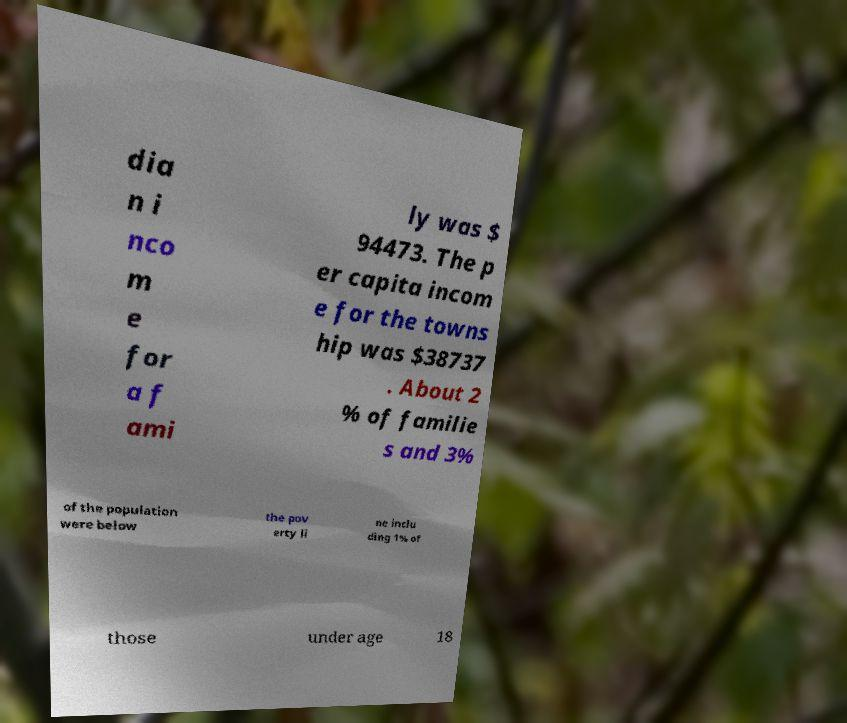Could you extract and type out the text from this image? dia n i nco m e for a f ami ly was $ 94473. The p er capita incom e for the towns hip was $38737 . About 2 % of familie s and 3% of the population were below the pov erty li ne inclu ding 1% of those under age 18 